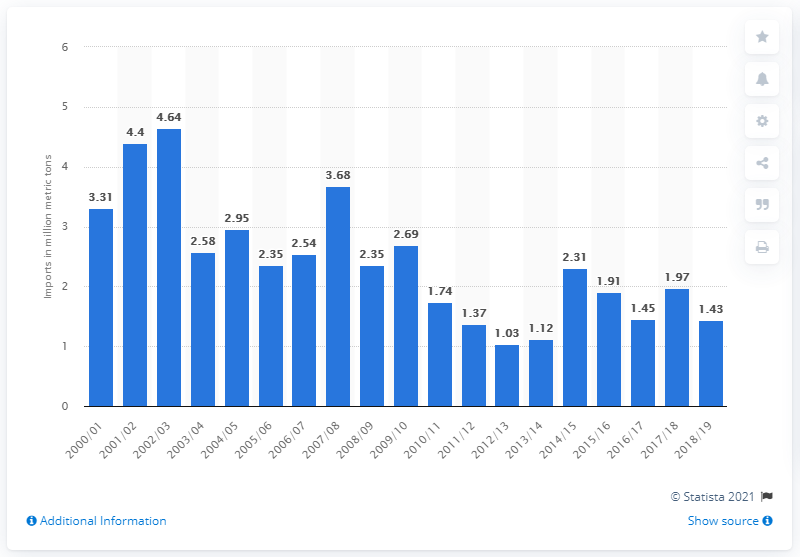Identify some key points in this picture. In the 2017/18 fiscal year, Canada's total imports of cereals were 1.97 million metric tons. 